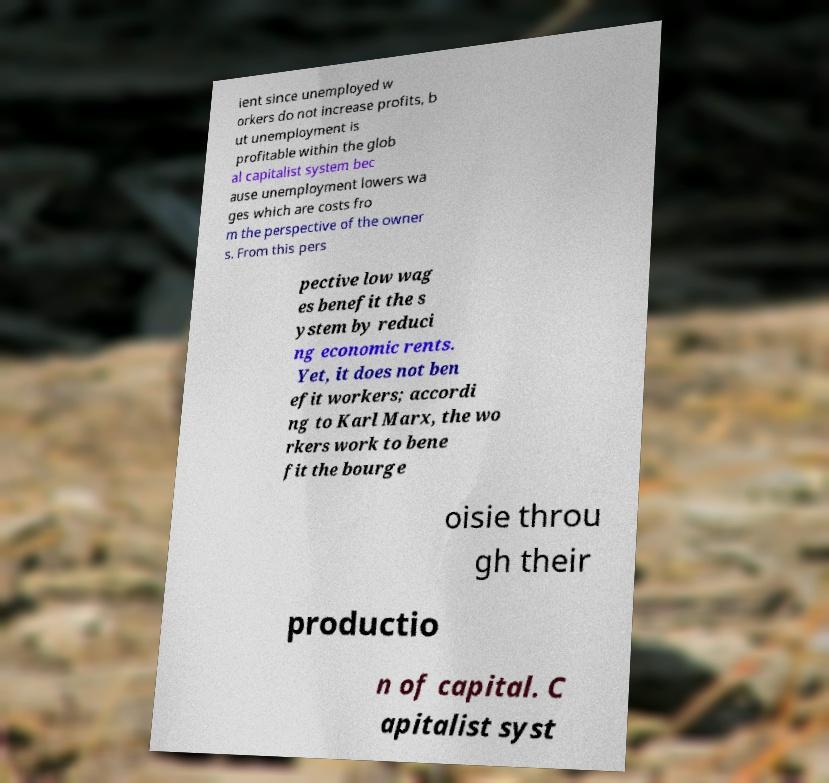There's text embedded in this image that I need extracted. Can you transcribe it verbatim? ient since unemployed w orkers do not increase profits, b ut unemployment is profitable within the glob al capitalist system bec ause unemployment lowers wa ges which are costs fro m the perspective of the owner s. From this pers pective low wag es benefit the s ystem by reduci ng economic rents. Yet, it does not ben efit workers; accordi ng to Karl Marx, the wo rkers work to bene fit the bourge oisie throu gh their productio n of capital. C apitalist syst 